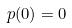Convert formula to latex. <formula><loc_0><loc_0><loc_500><loc_500>p ( 0 ) = 0</formula> 